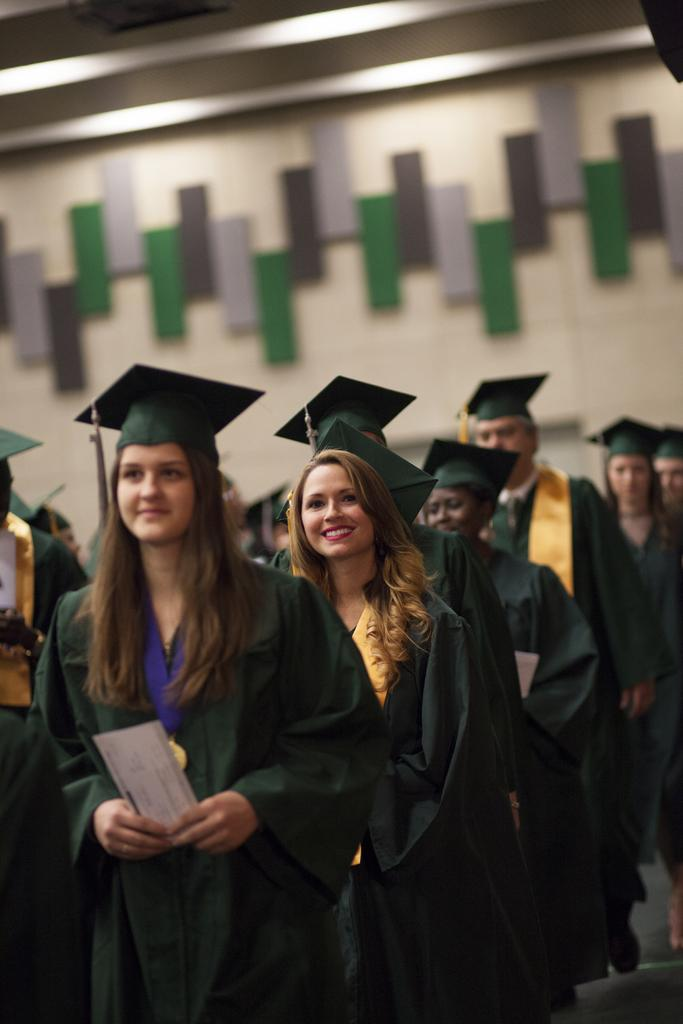How many people are in the image? There are people in the image, but the exact number is not specified. What are the people wearing in the image? The people are wearing coats and caps in the image. What is one of the people holding in the image? One of the people is holding a paper in the image. What can be seen on the wall in the background of the image? There are boards on the wall in the background of the image. What is visible at the top of the image? There is a roof visible at the top of the image. What type of detail can be seen on the rod in the image? There is no rod present in the image, so it is not possible to answer that question. 